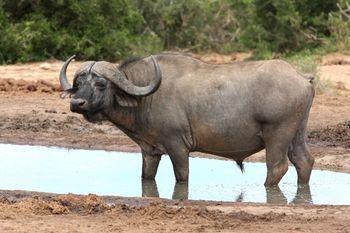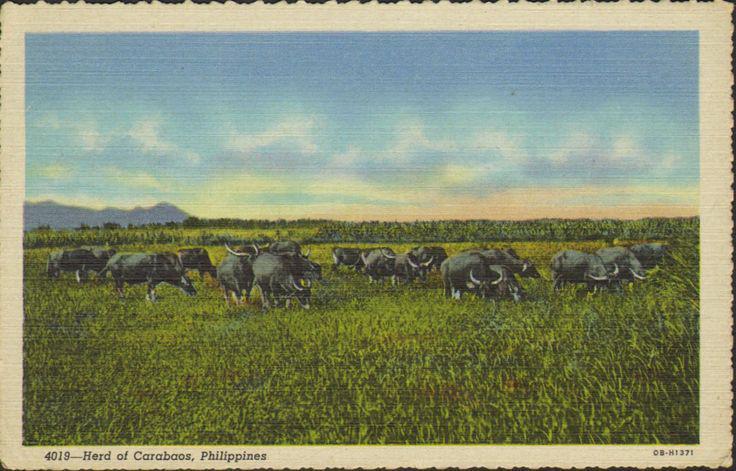The first image is the image on the left, the second image is the image on the right. Analyze the images presented: Is the assertion "The cow in the image on the left is walking through the water." valid? Answer yes or no. Yes. The first image is the image on the left, the second image is the image on the right. For the images shown, is this caption "One image features one horned animal standing in muddy water with its body turned leftward, and the other image features multiple hooved animals surrounded by greenery." true? Answer yes or no. Yes. 